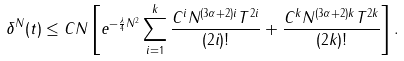<formula> <loc_0><loc_0><loc_500><loc_500>\delta ^ { N } ( t ) \leq C N \left [ e ^ { - \frac { \lambda } { 4 } N ^ { 2 } } \sum _ { i = 1 } ^ { k } \frac { C ^ { i } N ^ { ( 3 \alpha + 2 ) i } T ^ { 2 i } } { ( 2 i ) ! } + \frac { C ^ { k } N ^ { ( 3 \alpha + 2 ) k } T ^ { 2 k } } { ( 2 k ) ! } \right ] .</formula> 